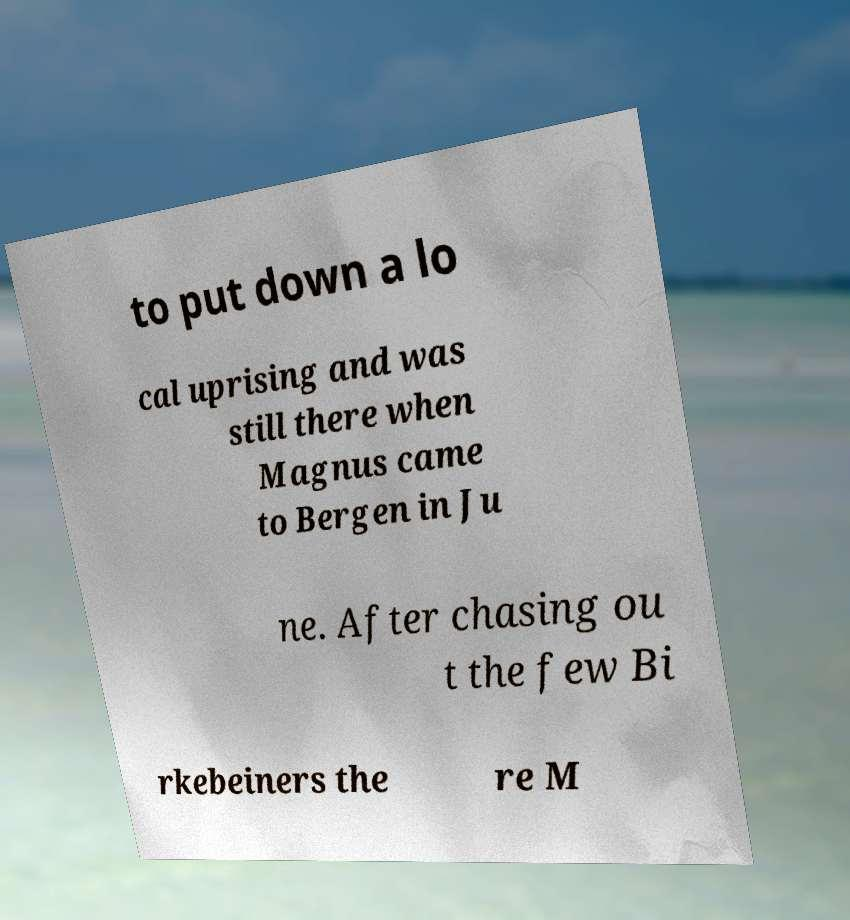What messages or text are displayed in this image? I need them in a readable, typed format. to put down a lo cal uprising and was still there when Magnus came to Bergen in Ju ne. After chasing ou t the few Bi rkebeiners the re M 